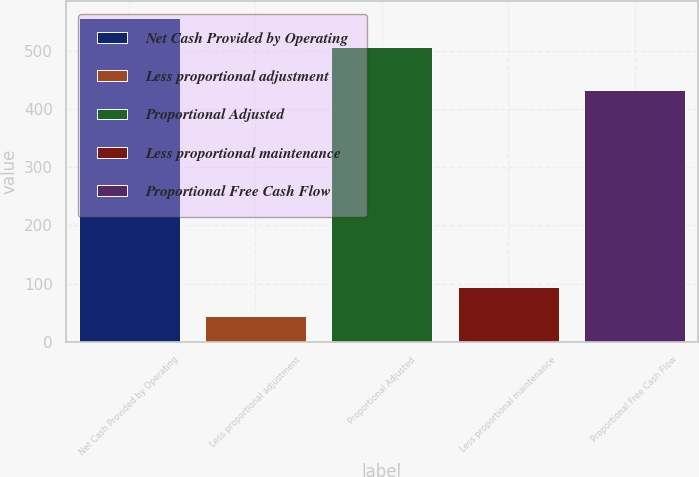<chart> <loc_0><loc_0><loc_500><loc_500><bar_chart><fcel>Net Cash Provided by Operating<fcel>Less proportional adjustment<fcel>Proportional Adjusted<fcel>Less proportional maintenance<fcel>Proportional Free Cash Flow<nl><fcel>556.6<fcel>44<fcel>506<fcel>94.6<fcel>433<nl></chart> 